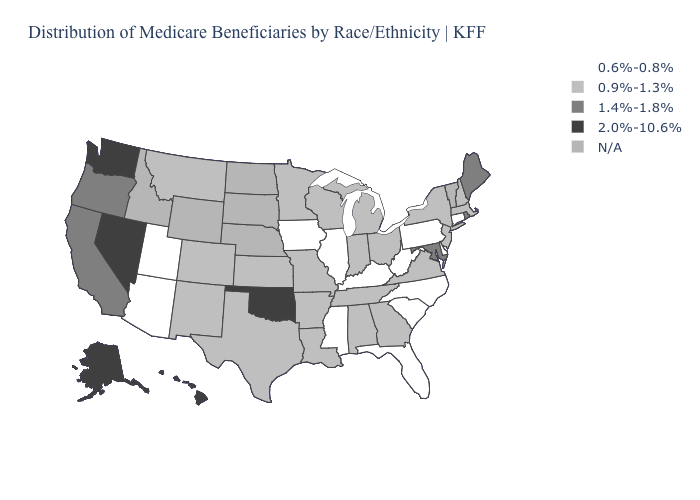Name the states that have a value in the range 1.4%-1.8%?
Write a very short answer. California, Maine, Maryland, Oregon, Rhode Island. What is the value of Montana?
Be succinct. 0.9%-1.3%. What is the value of Kentucky?
Keep it brief. 0.6%-0.8%. What is the lowest value in the USA?
Give a very brief answer. 0.6%-0.8%. Name the states that have a value in the range 0.6%-0.8%?
Give a very brief answer. Arizona, Connecticut, Delaware, Florida, Illinois, Iowa, Kentucky, Mississippi, North Carolina, Pennsylvania, South Carolina, Utah, West Virginia. Name the states that have a value in the range 0.6%-0.8%?
Write a very short answer. Arizona, Connecticut, Delaware, Florida, Illinois, Iowa, Kentucky, Mississippi, North Carolina, Pennsylvania, South Carolina, Utah, West Virginia. What is the lowest value in the MidWest?
Concise answer only. 0.6%-0.8%. Name the states that have a value in the range 0.9%-1.3%?
Be succinct. Alabama, Arkansas, Colorado, Georgia, Indiana, Kansas, Louisiana, Massachusetts, Michigan, Minnesota, Missouri, Montana, New Hampshire, New Jersey, New Mexico, New York, Ohio, Tennessee, Texas, Virginia, Wisconsin. How many symbols are there in the legend?
Quick response, please. 5. Among the states that border Wyoming , does Colorado have the lowest value?
Be succinct. No. Does Delaware have the lowest value in the South?
Keep it brief. Yes. What is the lowest value in the MidWest?
Short answer required. 0.6%-0.8%. Which states have the lowest value in the USA?
Short answer required. Arizona, Connecticut, Delaware, Florida, Illinois, Iowa, Kentucky, Mississippi, North Carolina, Pennsylvania, South Carolina, Utah, West Virginia. Which states hav the highest value in the West?
Write a very short answer. Alaska, Hawaii, Nevada, Washington. What is the lowest value in the Northeast?
Quick response, please. 0.6%-0.8%. 